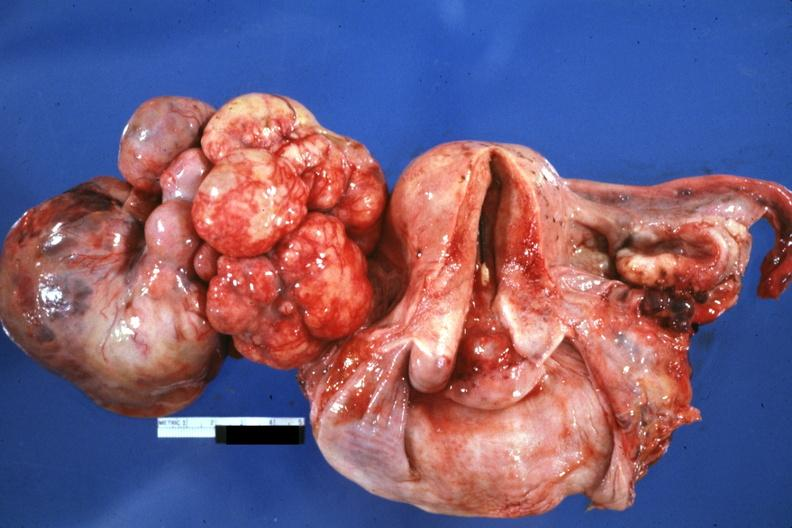s ovary present?
Answer the question using a single word or phrase. Yes 